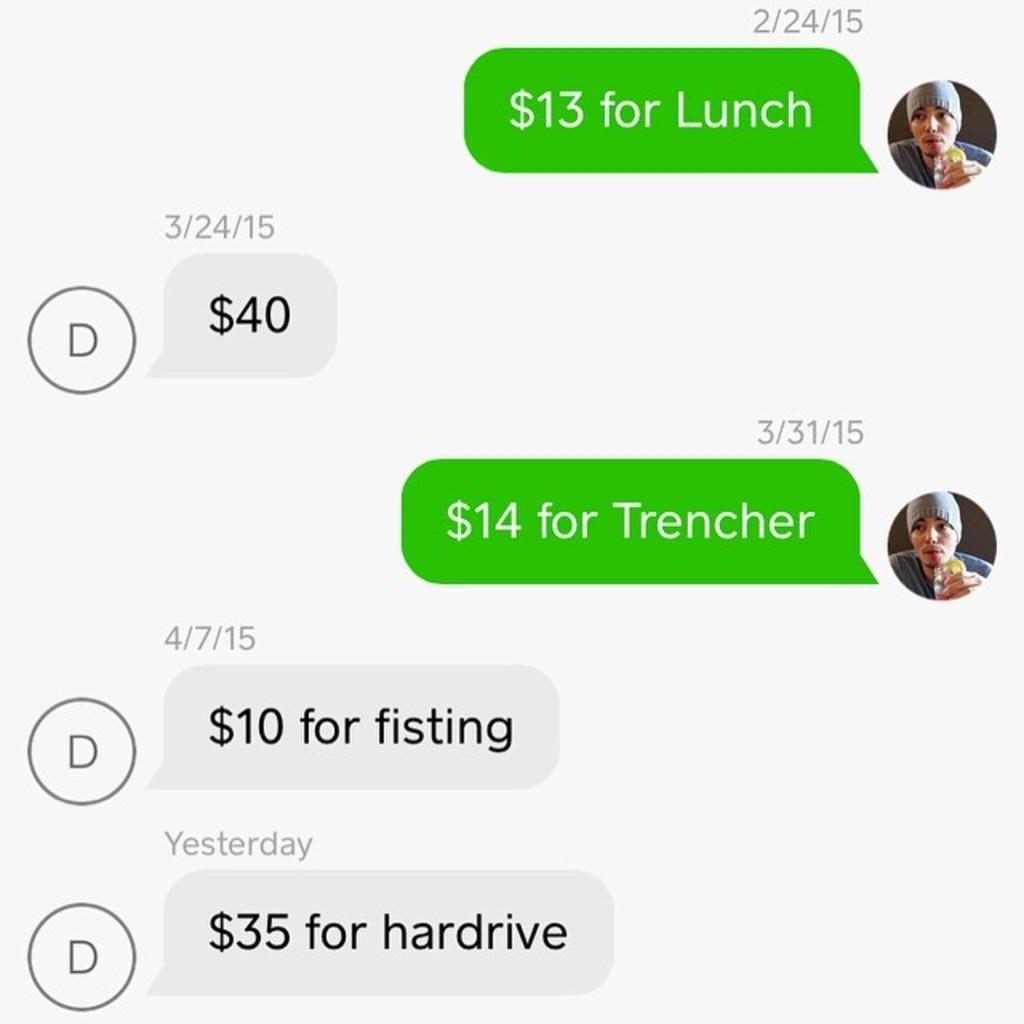Can you describe this image briefly? In the image there is a screenshot of a conversation. 